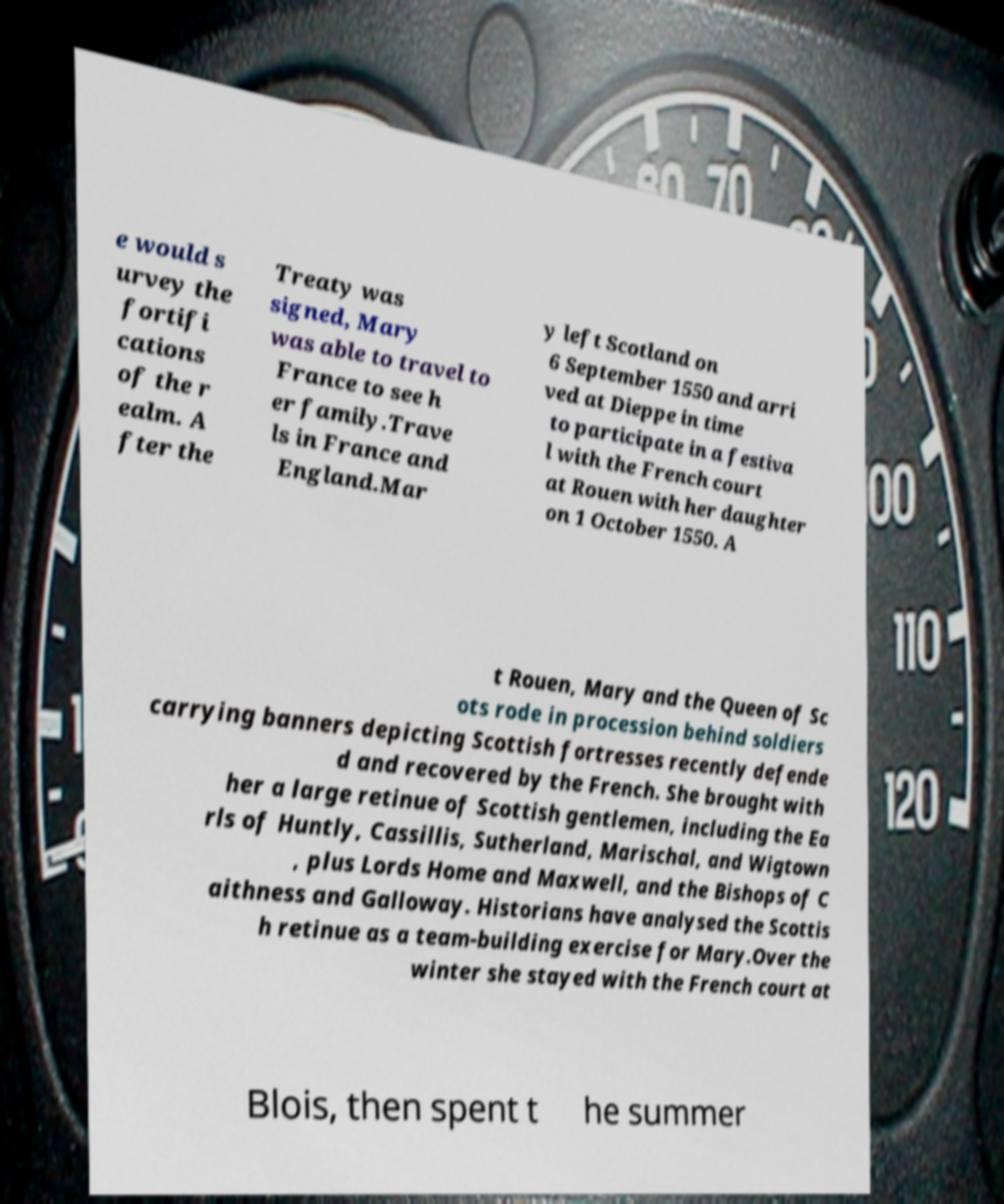There's text embedded in this image that I need extracted. Can you transcribe it verbatim? e would s urvey the fortifi cations of the r ealm. A fter the Treaty was signed, Mary was able to travel to France to see h er family.Trave ls in France and England.Mar y left Scotland on 6 September 1550 and arri ved at Dieppe in time to participate in a festiva l with the French court at Rouen with her daughter on 1 October 1550. A t Rouen, Mary and the Queen of Sc ots rode in procession behind soldiers carrying banners depicting Scottish fortresses recently defende d and recovered by the French. She brought with her a large retinue of Scottish gentlemen, including the Ea rls of Huntly, Cassillis, Sutherland, Marischal, and Wigtown , plus Lords Home and Maxwell, and the Bishops of C aithness and Galloway. Historians have analysed the Scottis h retinue as a team-building exercise for Mary.Over the winter she stayed with the French court at Blois, then spent t he summer 